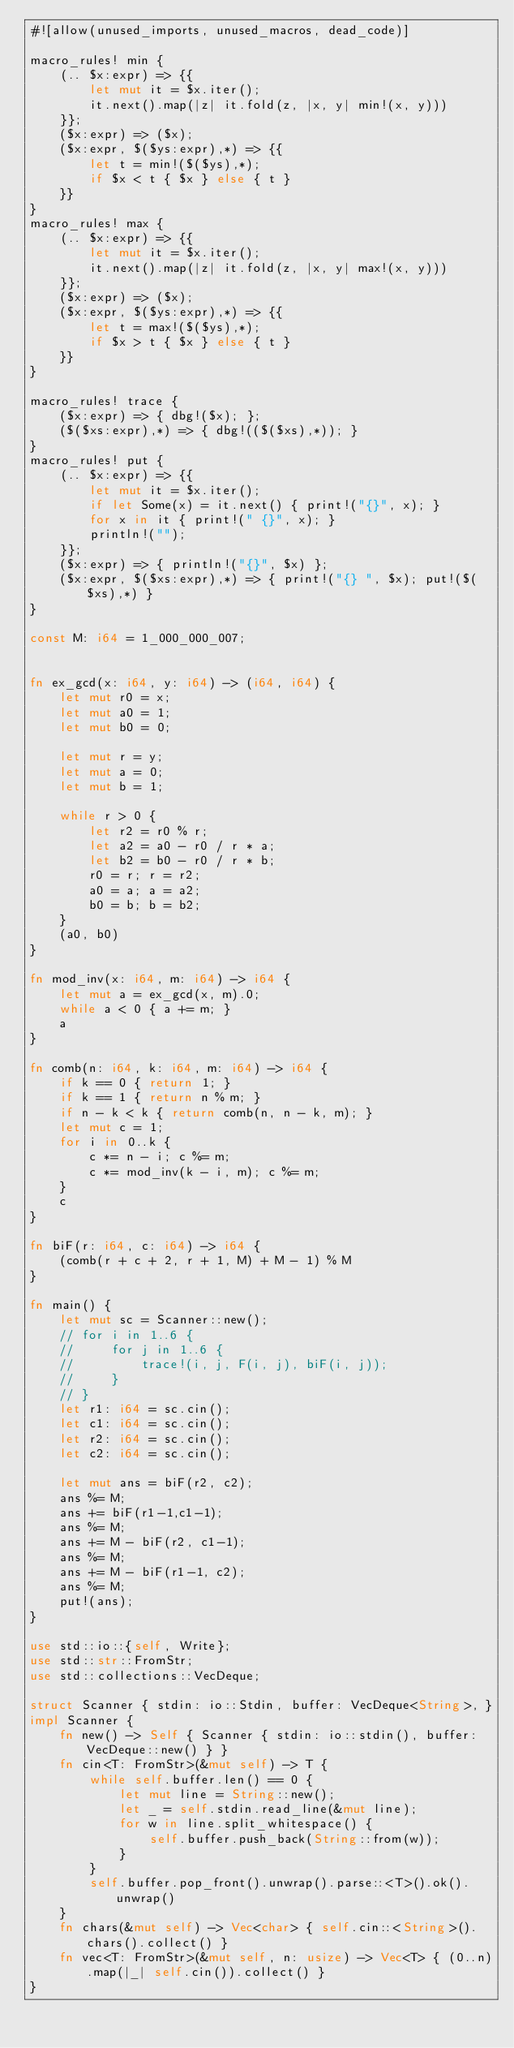<code> <loc_0><loc_0><loc_500><loc_500><_Rust_>#![allow(unused_imports, unused_macros, dead_code)]

macro_rules! min {
    (.. $x:expr) => {{
        let mut it = $x.iter();
        it.next().map(|z| it.fold(z, |x, y| min!(x, y)))
    }};
    ($x:expr) => ($x);
    ($x:expr, $($ys:expr),*) => {{
        let t = min!($($ys),*);
        if $x < t { $x } else { t }
    }}
}
macro_rules! max {
    (.. $x:expr) => {{
        let mut it = $x.iter();
        it.next().map(|z| it.fold(z, |x, y| max!(x, y)))
    }};
    ($x:expr) => ($x);
    ($x:expr, $($ys:expr),*) => {{
        let t = max!($($ys),*);
        if $x > t { $x } else { t }
    }}
}

macro_rules! trace {
    ($x:expr) => { dbg!($x); };
    ($($xs:expr),*) => { dbg!(($($xs),*)); }
}
macro_rules! put {
    (.. $x:expr) => {{
        let mut it = $x.iter();
        if let Some(x) = it.next() { print!("{}", x); }
        for x in it { print!(" {}", x); }
        println!("");
    }};
    ($x:expr) => { println!("{}", $x) };
    ($x:expr, $($xs:expr),*) => { print!("{} ", $x); put!($($xs),*) }
}

const M: i64 = 1_000_000_007;


fn ex_gcd(x: i64, y: i64) -> (i64, i64) {
    let mut r0 = x;
    let mut a0 = 1;
    let mut b0 = 0;

    let mut r = y;
    let mut a = 0;
    let mut b = 1;

    while r > 0 {
        let r2 = r0 % r;
        let a2 = a0 - r0 / r * a;
        let b2 = b0 - r0 / r * b;
        r0 = r; r = r2;
        a0 = a; a = a2;
        b0 = b; b = b2;
    }
    (a0, b0)
}

fn mod_inv(x: i64, m: i64) -> i64 {
    let mut a = ex_gcd(x, m).0;
    while a < 0 { a += m; }
    a
}

fn comb(n: i64, k: i64, m: i64) -> i64 {
    if k == 0 { return 1; }
    if k == 1 { return n % m; }
    if n - k < k { return comb(n, n - k, m); }
    let mut c = 1;
    for i in 0..k {
        c *= n - i; c %= m;
        c *= mod_inv(k - i, m); c %= m;
    }
    c
}

fn biF(r: i64, c: i64) -> i64 {
    (comb(r + c + 2, r + 1, M) + M - 1) % M
}

fn main() {
    let mut sc = Scanner::new();
    // for i in 1..6 {
    //     for j in 1..6 {
    //         trace!(i, j, F(i, j), biF(i, j));
    //     }
    // }
    let r1: i64 = sc.cin();
    let c1: i64 = sc.cin();
    let r2: i64 = sc.cin();
    let c2: i64 = sc.cin();

    let mut ans = biF(r2, c2);
    ans %= M;
    ans += biF(r1-1,c1-1);
    ans %= M;
    ans += M - biF(r2, c1-1);
    ans %= M;
    ans += M - biF(r1-1, c2);
    ans %= M;
    put!(ans);
}

use std::io::{self, Write};
use std::str::FromStr;
use std::collections::VecDeque;

struct Scanner { stdin: io::Stdin, buffer: VecDeque<String>, }
impl Scanner {
    fn new() -> Self { Scanner { stdin: io::stdin(), buffer: VecDeque::new() } }
    fn cin<T: FromStr>(&mut self) -> T {
        while self.buffer.len() == 0 {
            let mut line = String::new();
            let _ = self.stdin.read_line(&mut line);
            for w in line.split_whitespace() {
                self.buffer.push_back(String::from(w));
            }
        }
        self.buffer.pop_front().unwrap().parse::<T>().ok().unwrap()
    }
    fn chars(&mut self) -> Vec<char> { self.cin::<String>().chars().collect() }
    fn vec<T: FromStr>(&mut self, n: usize) -> Vec<T> { (0..n).map(|_| self.cin()).collect() }
}
</code> 